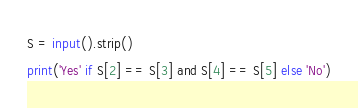Convert code to text. <code><loc_0><loc_0><loc_500><loc_500><_Python_>S = input().strip()
print('Yes' if S[2] == S[3] and S[4] == S[5] else 'No')
</code> 